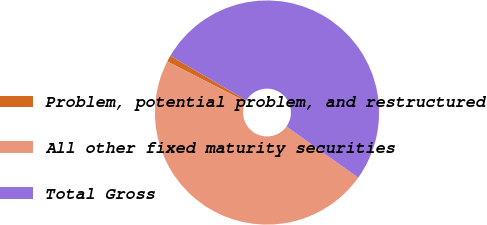Convert chart. <chart><loc_0><loc_0><loc_500><loc_500><pie_chart><fcel>Problem, potential problem, and restructured<fcel>All other fixed maturity securities<fcel>Total Gross<nl><fcel>0.92%<fcel>47.67%<fcel>51.41%<nl></chart> 